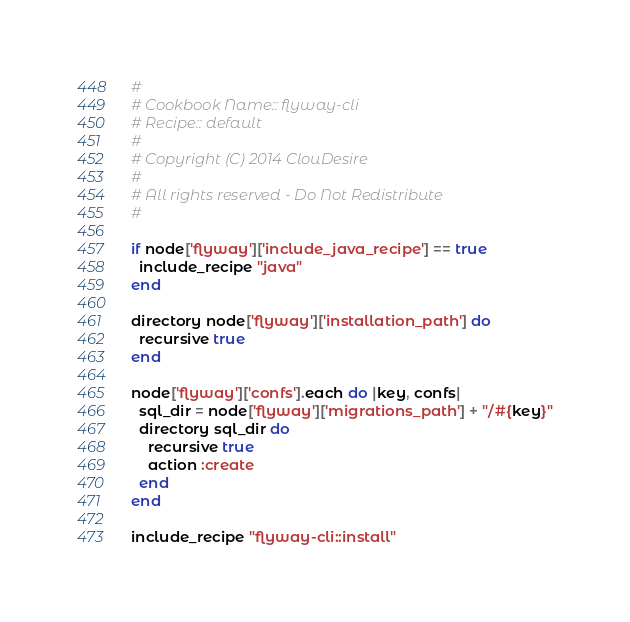Convert code to text. <code><loc_0><loc_0><loc_500><loc_500><_Ruby_>#
# Cookbook Name:: flyway-cli
# Recipe:: default
#
# Copyright (C) 2014 ClouDesire
#
# All rights reserved - Do Not Redistribute
#

if node['flyway']['include_java_recipe'] == true
  include_recipe "java"
end

directory node['flyway']['installation_path'] do
  recursive true
end

node['flyway']['confs'].each do |key, confs|
  sql_dir = node['flyway']['migrations_path'] + "/#{key}"
  directory sql_dir do
    recursive true
    action :create
  end
end

include_recipe "flyway-cli::install"
</code> 